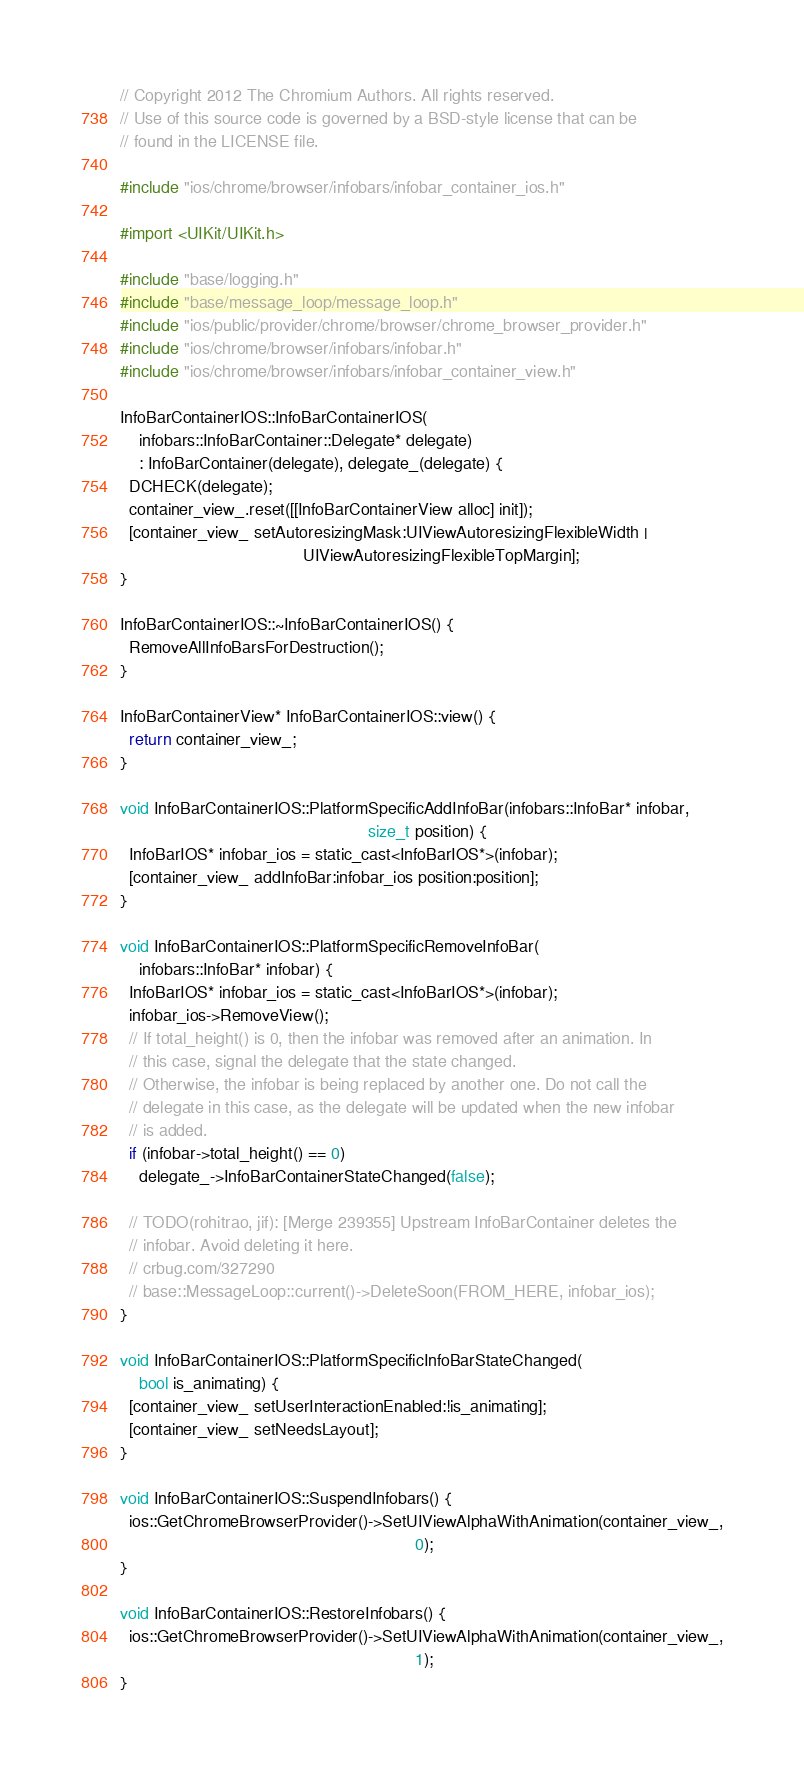Convert code to text. <code><loc_0><loc_0><loc_500><loc_500><_ObjectiveC_>// Copyright 2012 The Chromium Authors. All rights reserved.
// Use of this source code is governed by a BSD-style license that can be
// found in the LICENSE file.

#include "ios/chrome/browser/infobars/infobar_container_ios.h"

#import <UIKit/UIKit.h>

#include "base/logging.h"
#include "base/message_loop/message_loop.h"
#include "ios/public/provider/chrome/browser/chrome_browser_provider.h"
#include "ios/chrome/browser/infobars/infobar.h"
#include "ios/chrome/browser/infobars/infobar_container_view.h"

InfoBarContainerIOS::InfoBarContainerIOS(
    infobars::InfoBarContainer::Delegate* delegate)
    : InfoBarContainer(delegate), delegate_(delegate) {
  DCHECK(delegate);
  container_view_.reset([[InfoBarContainerView alloc] init]);
  [container_view_ setAutoresizingMask:UIViewAutoresizingFlexibleWidth |
                                       UIViewAutoresizingFlexibleTopMargin];
}

InfoBarContainerIOS::~InfoBarContainerIOS() {
  RemoveAllInfoBarsForDestruction();
}

InfoBarContainerView* InfoBarContainerIOS::view() {
  return container_view_;
}

void InfoBarContainerIOS::PlatformSpecificAddInfoBar(infobars::InfoBar* infobar,
                                                     size_t position) {
  InfoBarIOS* infobar_ios = static_cast<InfoBarIOS*>(infobar);
  [container_view_ addInfoBar:infobar_ios position:position];
}

void InfoBarContainerIOS::PlatformSpecificRemoveInfoBar(
    infobars::InfoBar* infobar) {
  InfoBarIOS* infobar_ios = static_cast<InfoBarIOS*>(infobar);
  infobar_ios->RemoveView();
  // If total_height() is 0, then the infobar was removed after an animation. In
  // this case, signal the delegate that the state changed.
  // Otherwise, the infobar is being replaced by another one. Do not call the
  // delegate in this case, as the delegate will be updated when the new infobar
  // is added.
  if (infobar->total_height() == 0)
    delegate_->InfoBarContainerStateChanged(false);

  // TODO(rohitrao, jif): [Merge 239355] Upstream InfoBarContainer deletes the
  // infobar. Avoid deleting it here.
  // crbug.com/327290
  // base::MessageLoop::current()->DeleteSoon(FROM_HERE, infobar_ios);
}

void InfoBarContainerIOS::PlatformSpecificInfoBarStateChanged(
    bool is_animating) {
  [container_view_ setUserInteractionEnabled:!is_animating];
  [container_view_ setNeedsLayout];
}

void InfoBarContainerIOS::SuspendInfobars() {
  ios::GetChromeBrowserProvider()->SetUIViewAlphaWithAnimation(container_view_,
                                                               0);
}

void InfoBarContainerIOS::RestoreInfobars() {
  ios::GetChromeBrowserProvider()->SetUIViewAlphaWithAnimation(container_view_,
                                                               1);
}
</code> 